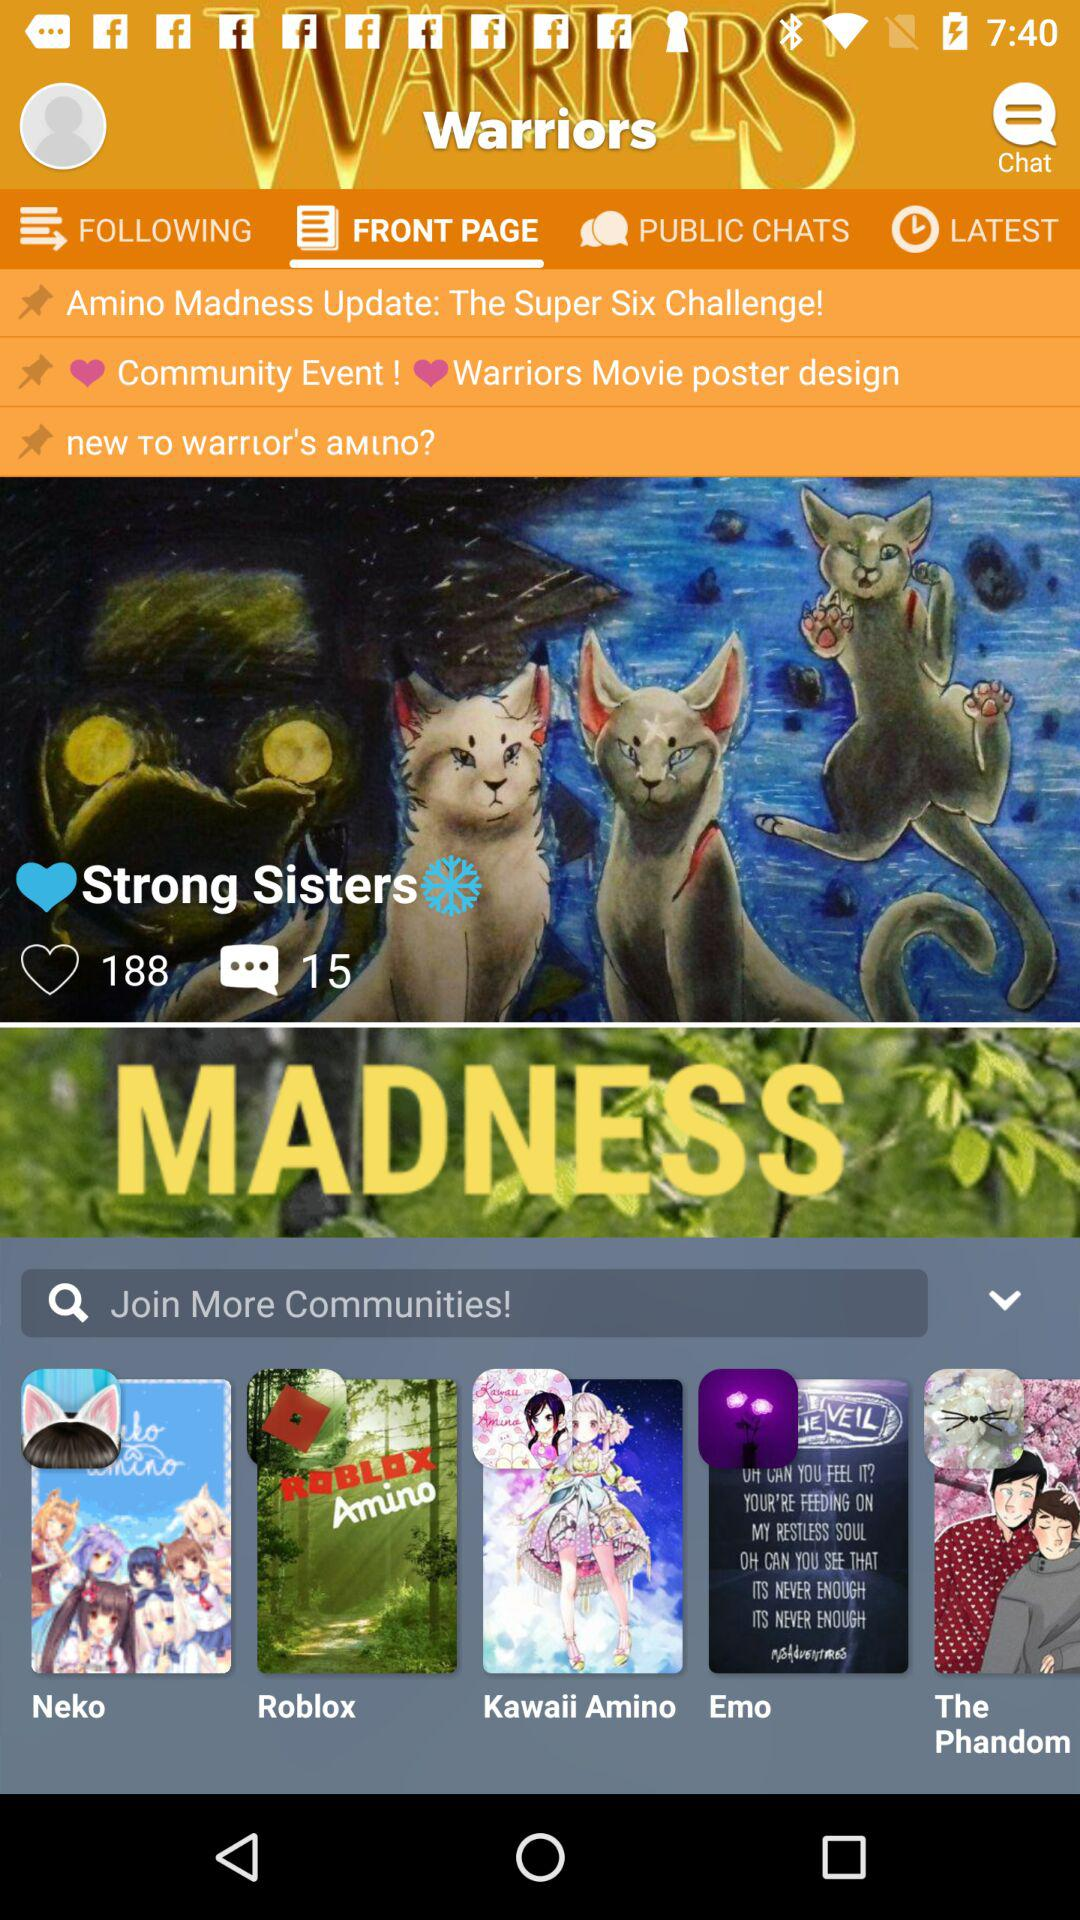What's the number of comments on the "Strong Sisters"? The number of comments on the "Strong Sisters" is 15. 